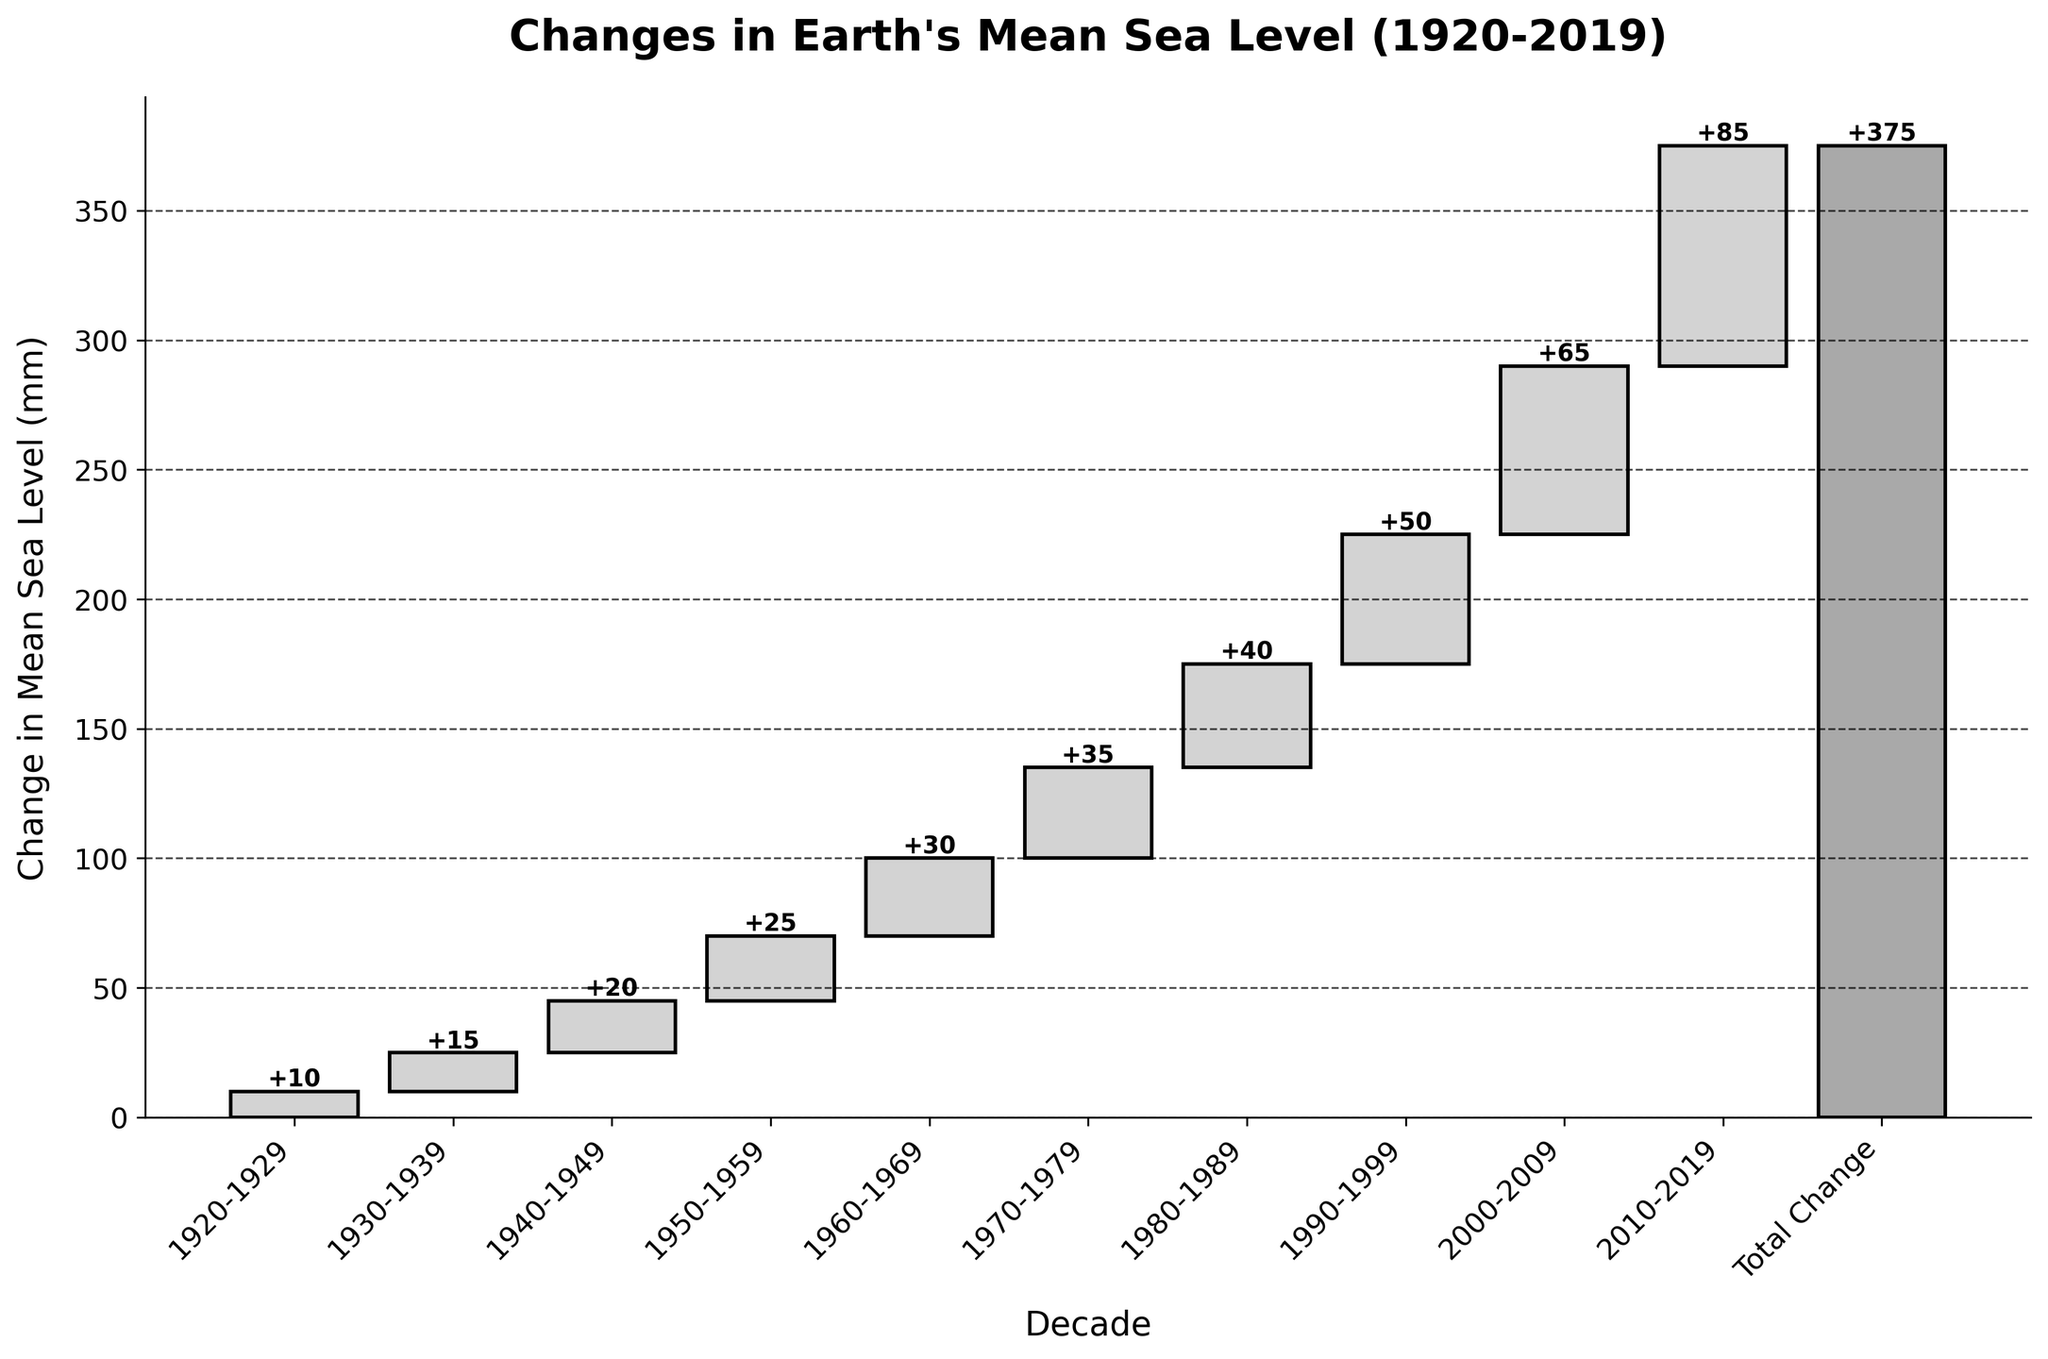What is the title of the chart? The title of the chart is displayed at the top and reads "Changes in Earth's Mean Sea Level (1920-2019)" which indicates the focus on sea level changes over time.
Answer: Changes in Earth's Mean Sea Level (1920-2019) How many decades are represented in the chart? The x-axis labels represent each decade, from 1920-1929 to 2010-2019, making a total of 10 decades.
Answer: 10 What is the change in mean sea level during the 1940-1949 decade? The bar corresponding to the 1940-1949 decade indicates a change of 20 mm, which is clearly marked on the chart.
Answer: 20 mm Which decade had the highest change in mean sea level? By examining the height of the bars, the decade 2010-2019 has the highest change in mean sea level, indicated by an 85 mm increase.
Answer: 2010-2019 What is the total change in mean sea level from 1920-2019? The total change is explicitly labeled on the chart as 375 mm, summarizing the cumulative changes across all decades.
Answer: 375 mm What was the change in mean sea level from 1950-1979? To get the change from 1950-1979, add the values for the three decades: 1950-1959 (25 mm), 1960-1969 (30 mm), and 1970-1979 (35 mm). Summing these gives 25 + 30 + 35 = 90 mm.
Answer: 90 mm How does the change in mean sea level from 2000-2009 compare to the change from 1990-1999? The change from 2000-2009 is 65 mm, while from 1990-1999 it is 50 mm. Since 65 is greater than 50, the 2000-2009 decade had a larger increase.
Answer: 2000-2009 > 1990-1999 What is the difference in mean sea level change between the 1930-1939 and 1960-1969 decades? The change for 1930-1939 is 15 mm, and for 1960-1969, it is 30 mm. The difference is 30 - 15 = 15 mm.
Answer: 15 mm What percentage of the total change occurred in the 2010-2019 decade? The change in the 2010-2019 decade is 85 mm, and the total change is 375 mm. The percentage is (85 / 375) * 100 ≈ 22.67%.
Answer: ~22.67% How did the change in mean sea level evolve from the first to the last decade in the chart? From 1920-2019, the change in mean sea level transitioned from an increase of 10 mm to an increase of 85 mm as shown by the first and last bars respectively, showing a clear upward trend.
Answer: Upward trend from 10 mm to 85 mm 